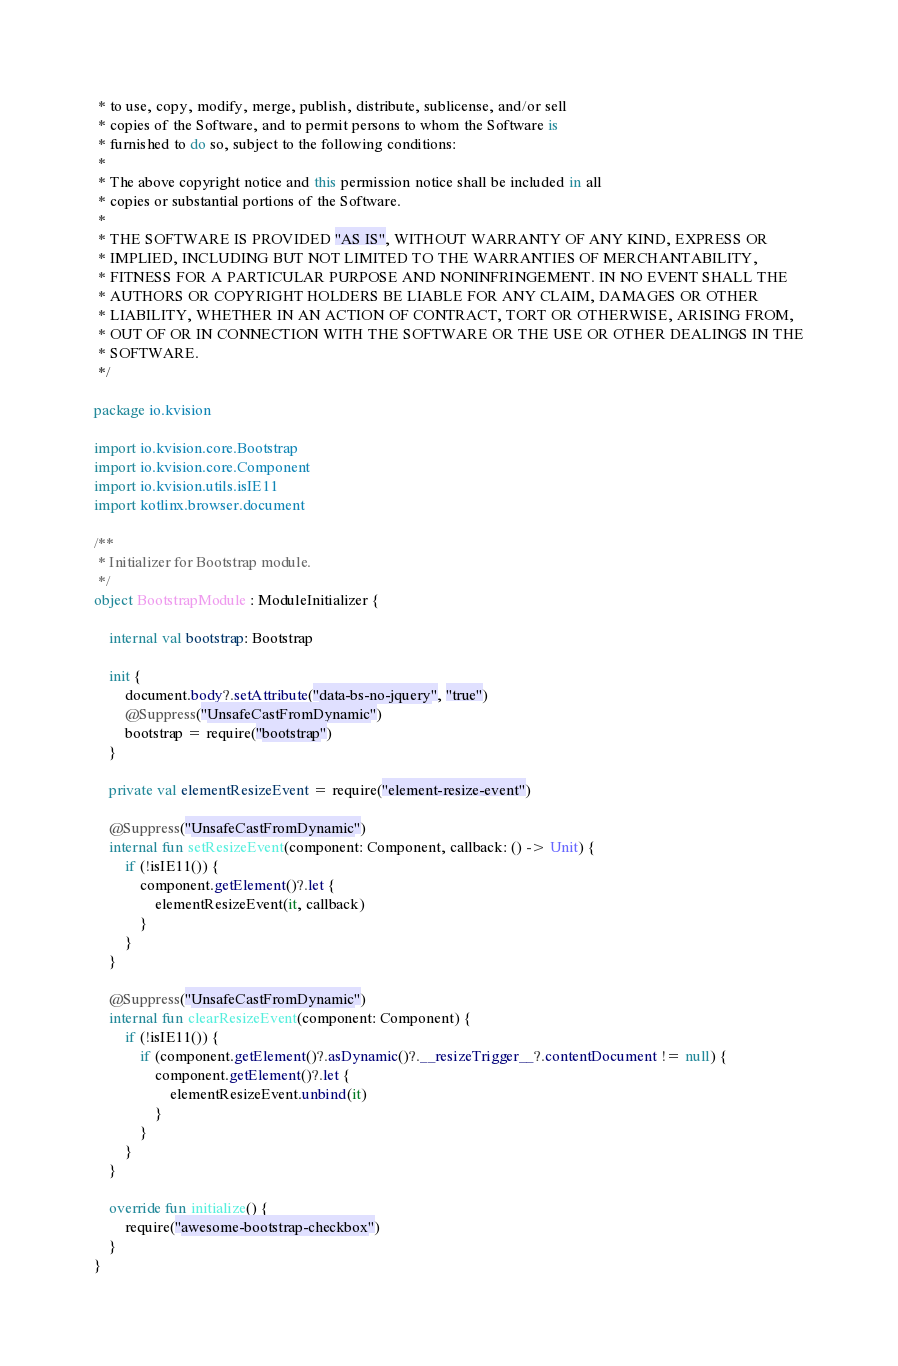Convert code to text. <code><loc_0><loc_0><loc_500><loc_500><_Kotlin_> * to use, copy, modify, merge, publish, distribute, sublicense, and/or sell
 * copies of the Software, and to permit persons to whom the Software is
 * furnished to do so, subject to the following conditions:
 *
 * The above copyright notice and this permission notice shall be included in all
 * copies or substantial portions of the Software.
 *
 * THE SOFTWARE IS PROVIDED "AS IS", WITHOUT WARRANTY OF ANY KIND, EXPRESS OR
 * IMPLIED, INCLUDING BUT NOT LIMITED TO THE WARRANTIES OF MERCHANTABILITY,
 * FITNESS FOR A PARTICULAR PURPOSE AND NONINFRINGEMENT. IN NO EVENT SHALL THE
 * AUTHORS OR COPYRIGHT HOLDERS BE LIABLE FOR ANY CLAIM, DAMAGES OR OTHER
 * LIABILITY, WHETHER IN AN ACTION OF CONTRACT, TORT OR OTHERWISE, ARISING FROM,
 * OUT OF OR IN CONNECTION WITH THE SOFTWARE OR THE USE OR OTHER DEALINGS IN THE
 * SOFTWARE.
 */

package io.kvision

import io.kvision.core.Bootstrap
import io.kvision.core.Component
import io.kvision.utils.isIE11
import kotlinx.browser.document

/**
 * Initializer for Bootstrap module.
 */
object BootstrapModule : ModuleInitializer {

    internal val bootstrap: Bootstrap

    init {
        document.body?.setAttribute("data-bs-no-jquery", "true")
        @Suppress("UnsafeCastFromDynamic")
        bootstrap = require("bootstrap")
    }

    private val elementResizeEvent = require("element-resize-event")

    @Suppress("UnsafeCastFromDynamic")
    internal fun setResizeEvent(component: Component, callback: () -> Unit) {
        if (!isIE11()) {
            component.getElement()?.let {
                elementResizeEvent(it, callback)
            }
        }
    }

    @Suppress("UnsafeCastFromDynamic")
    internal fun clearResizeEvent(component: Component) {
        if (!isIE11()) {
            if (component.getElement()?.asDynamic()?.__resizeTrigger__?.contentDocument != null) {
                component.getElement()?.let {
                    elementResizeEvent.unbind(it)
                }
            }
        }
    }

    override fun initialize() {
        require("awesome-bootstrap-checkbox")
    }
}
</code> 